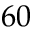Convert formula to latex. <formula><loc_0><loc_0><loc_500><loc_500>6 0</formula> 